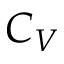<formula> <loc_0><loc_0><loc_500><loc_500>C _ { V }</formula> 